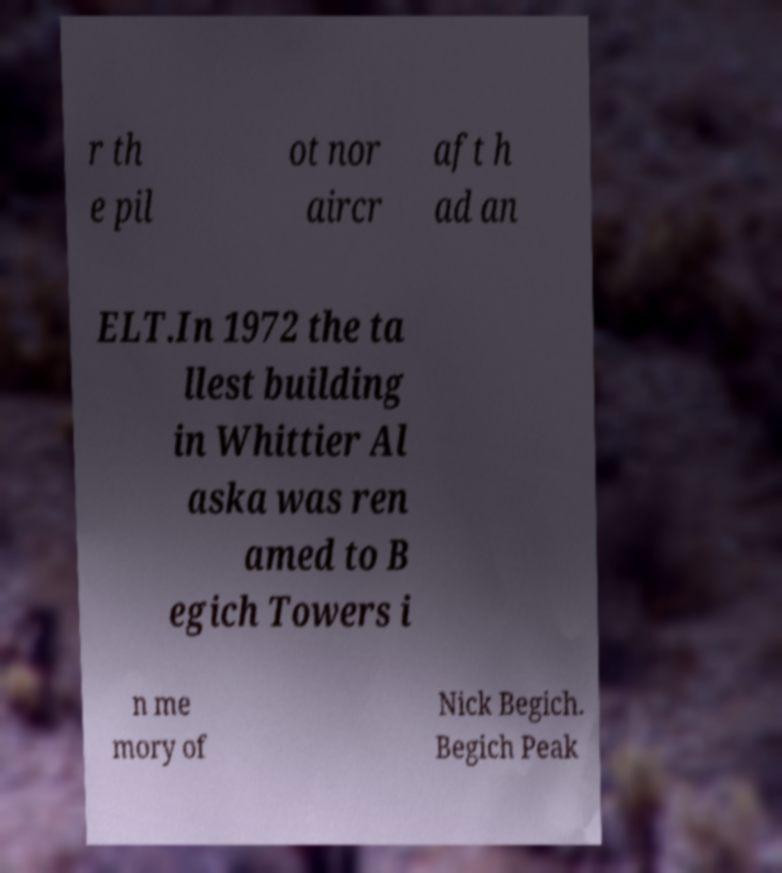Can you accurately transcribe the text from the provided image for me? r th e pil ot nor aircr aft h ad an ELT.In 1972 the ta llest building in Whittier Al aska was ren amed to B egich Towers i n me mory of Nick Begich. Begich Peak 